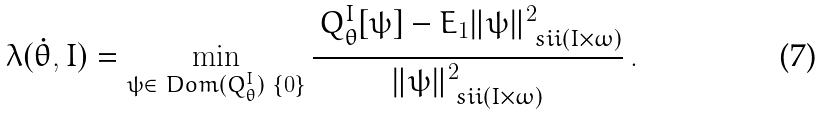Convert formula to latex. <formula><loc_0><loc_0><loc_500><loc_500>\lambda ( \dot { \theta } , I ) = \min _ { \psi \in \ D o m ( Q _ { \theta } ^ { I } ) \ \{ 0 \} } \frac { \, Q _ { \theta } ^ { I } [ \psi ] - E _ { 1 } \| \psi \| _ { \ s i i ( I \times \omega ) } ^ { 2 } } { \| \psi \| _ { \ s i i ( I \times \omega ) } ^ { 2 } } \, .</formula> 